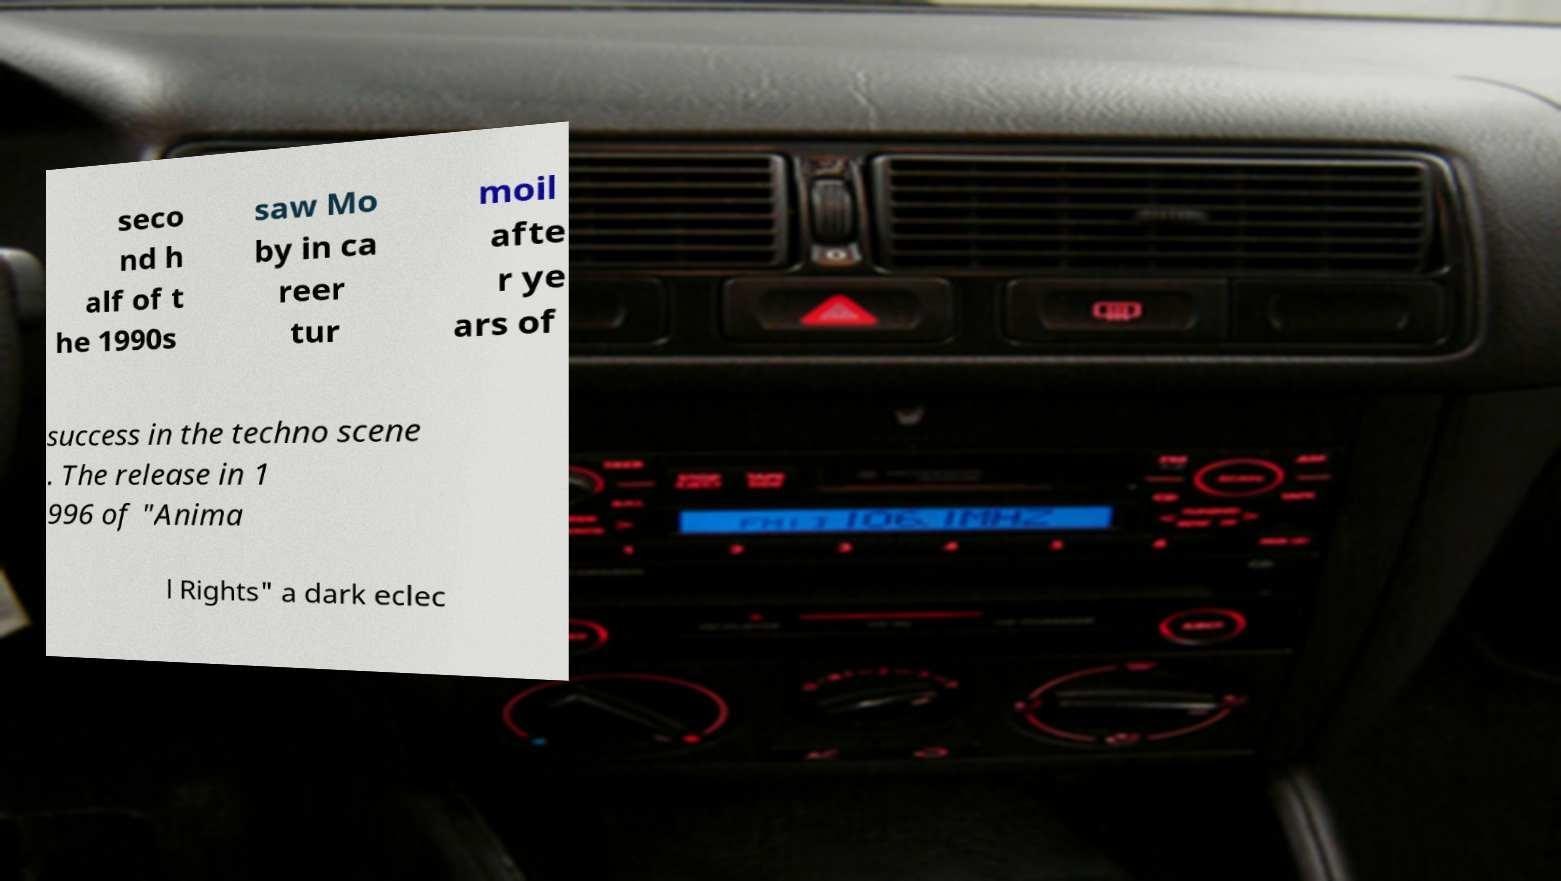Can you accurately transcribe the text from the provided image for me? seco nd h alf of t he 1990s saw Mo by in ca reer tur moil afte r ye ars of success in the techno scene . The release in 1 996 of "Anima l Rights" a dark eclec 